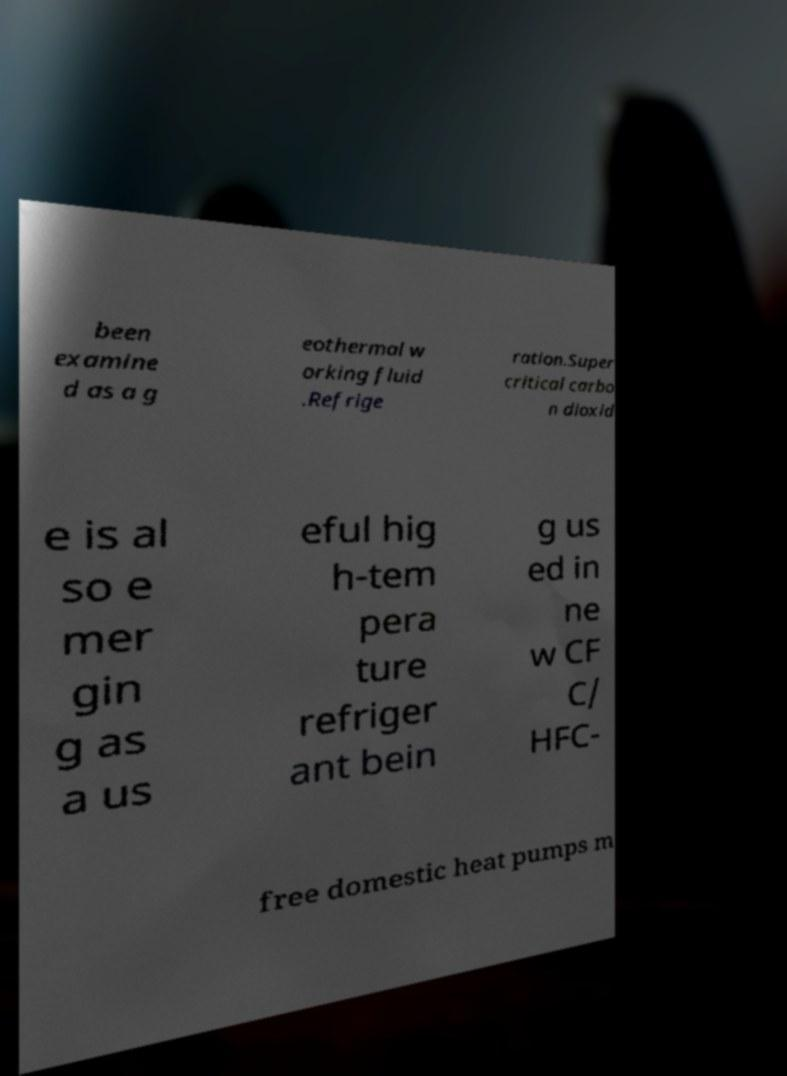Please identify and transcribe the text found in this image. been examine d as a g eothermal w orking fluid .Refrige ration.Super critical carbo n dioxid e is al so e mer gin g as a us eful hig h-tem pera ture refriger ant bein g us ed in ne w CF C/ HFC- free domestic heat pumps m 